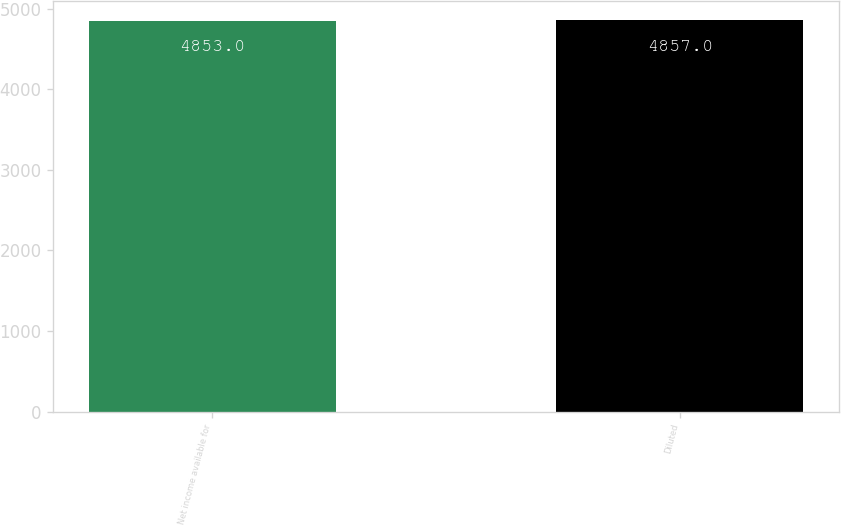<chart> <loc_0><loc_0><loc_500><loc_500><bar_chart><fcel>Net income available for<fcel>Diluted<nl><fcel>4853<fcel>4857<nl></chart> 